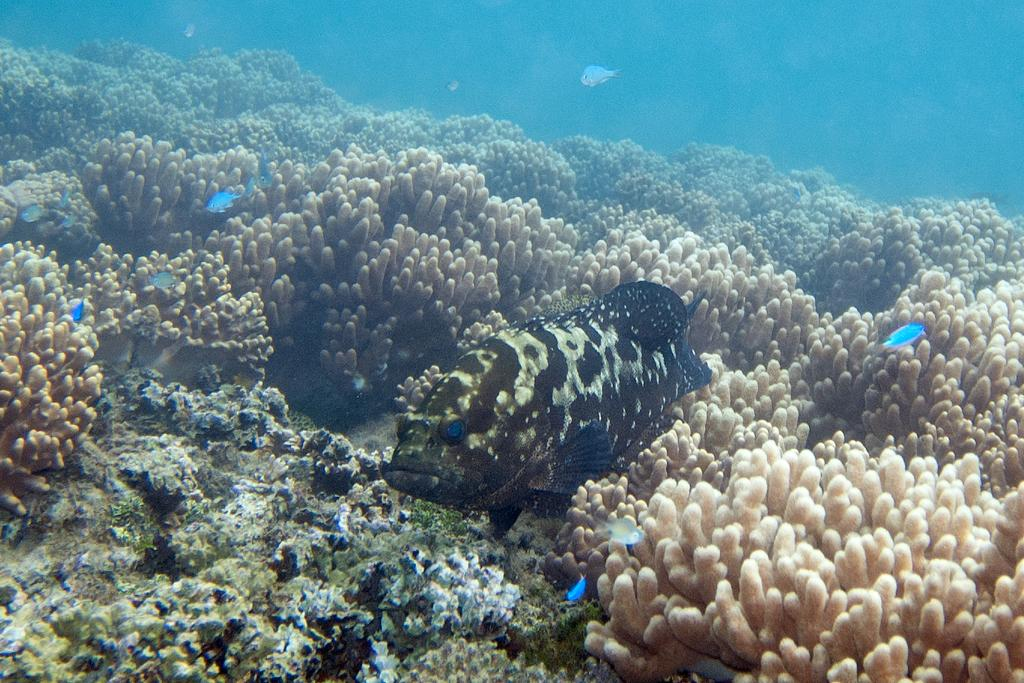What is the main subject of the image? The main subject of the image is fish visible underwater in the center of the image. Are there any other fish in the image? Yes, there are fish in the background of the image. What type of vegetation can be seen in the background? Coral leaves are present in the background of the image. How many steps are visible in the image? There are no steps present in the image; it features underwater fish and coral leaves. What type of friction can be observed between the fish and the coral leaves? There is no friction between the fish and the coral leaves visible in the image, as they are both submerged in water. 